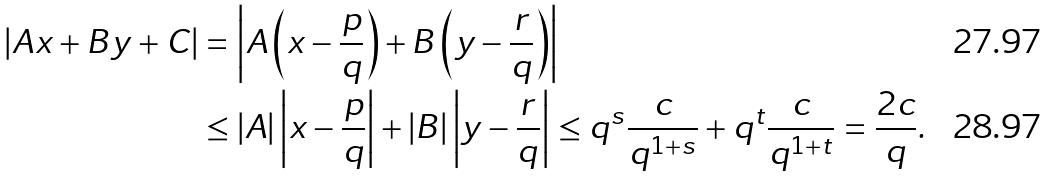<formula> <loc_0><loc_0><loc_500><loc_500>| A x + B y + C | & = \left | A \left ( x - \frac { p } { q } \right ) + B \left ( y - \frac { r } { q } \right ) \right | \\ & \leq | A | \left | x - \frac { p } { q } \right | + | B | \left | y - \frac { r } { q } \right | \leq q ^ { s } \frac { c } { q ^ { 1 + s } } + q ^ { t } \frac { c } { q ^ { 1 + t } } = \frac { 2 c } { q } .</formula> 